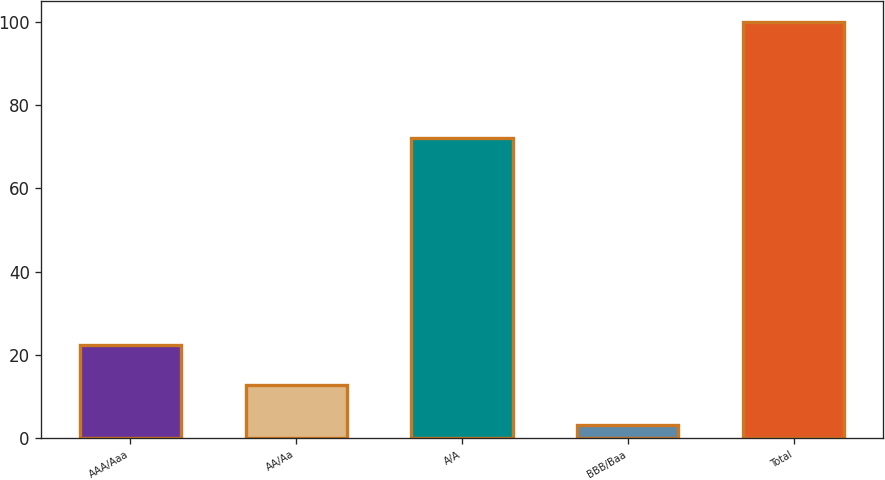Convert chart. <chart><loc_0><loc_0><loc_500><loc_500><bar_chart><fcel>AAA/Aaa<fcel>AA/Aa<fcel>A/A<fcel>BBB/Baa<fcel>Total<nl><fcel>22.4<fcel>12.7<fcel>72<fcel>3<fcel>100<nl></chart> 